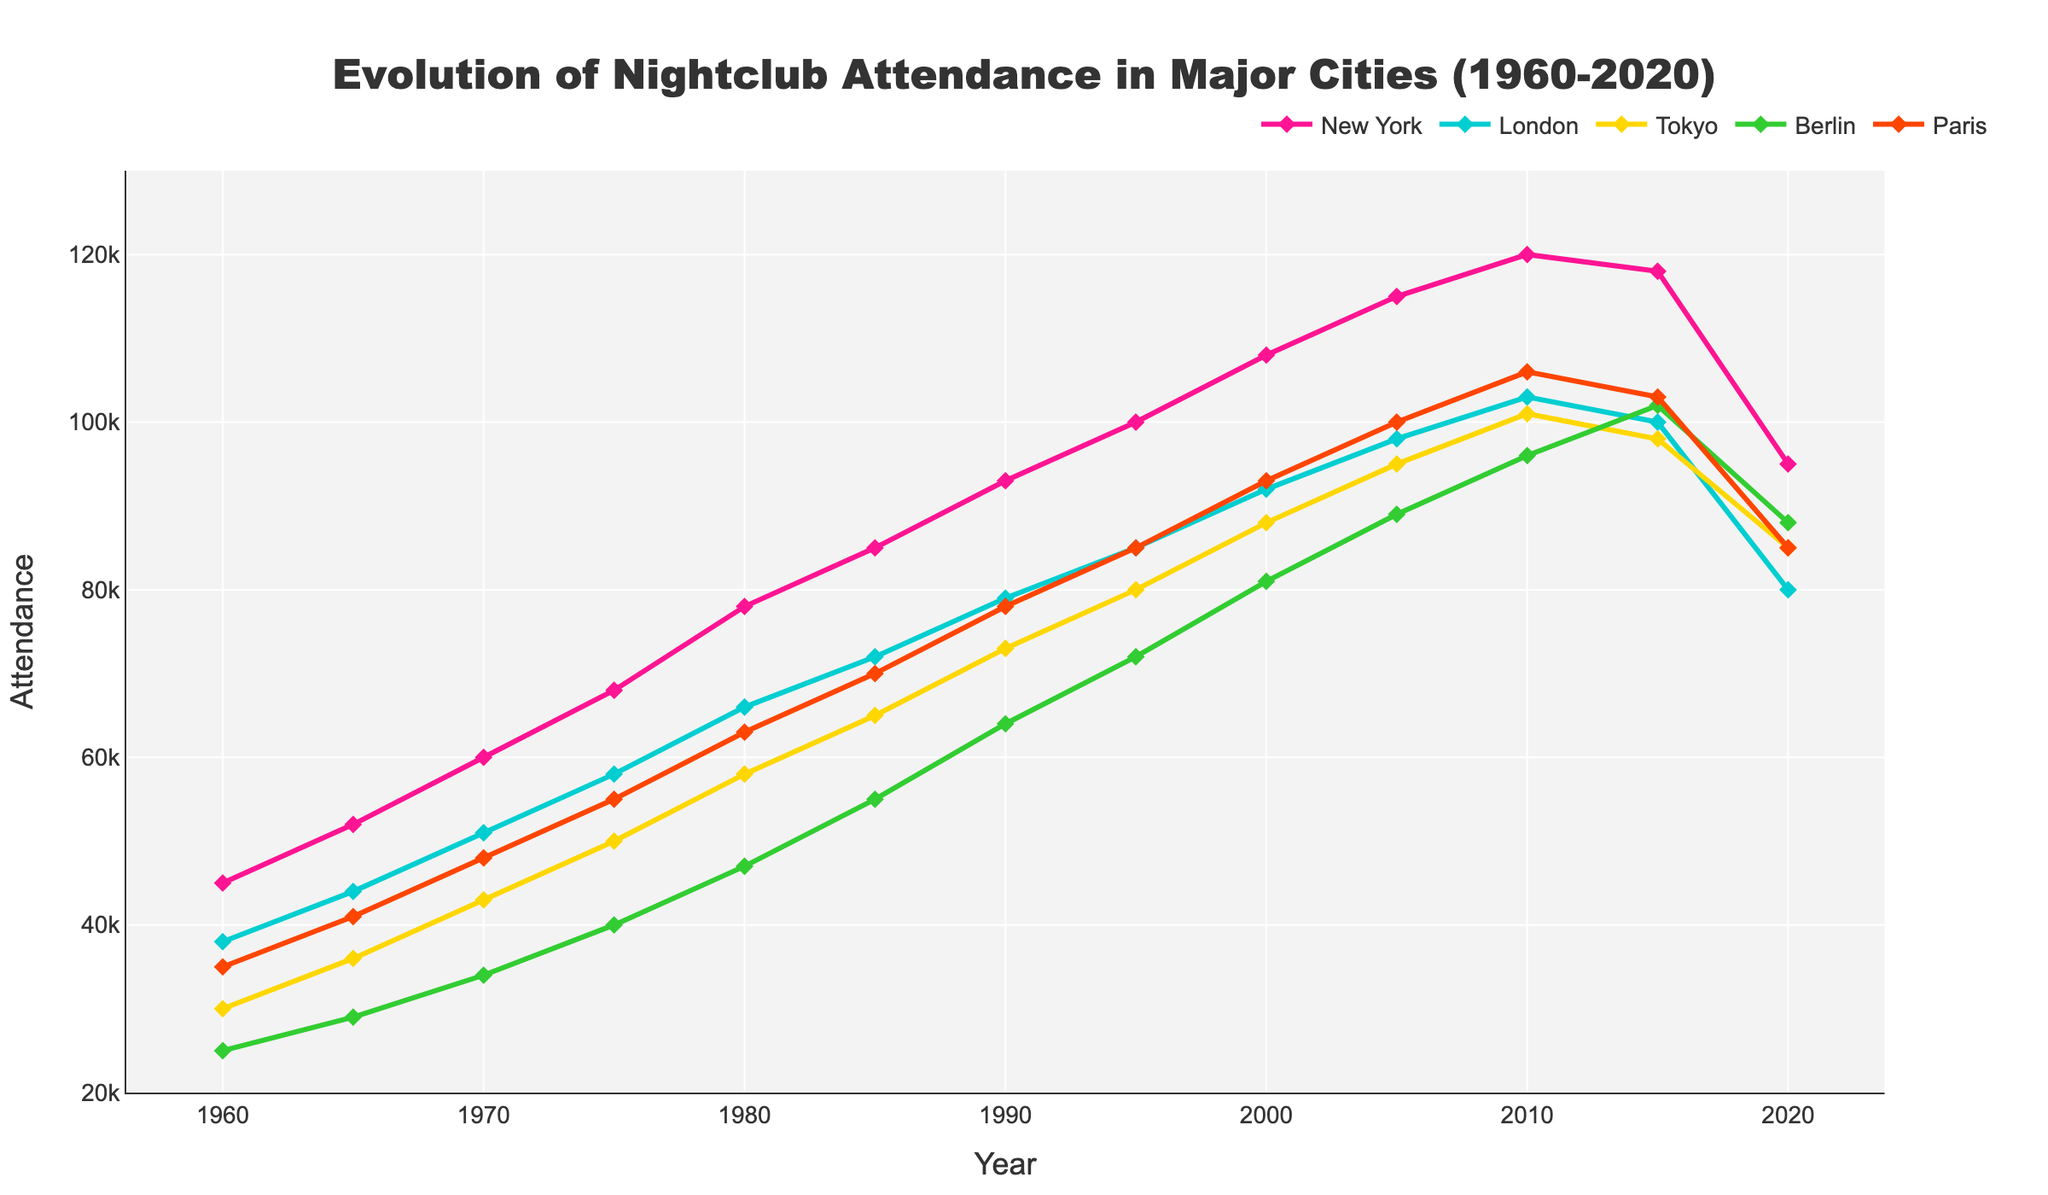Which city had the highest nightclub attendance in 1980? From the chart, the line representing New York in 1980 reaches the highest position among all cities in that year.
Answer: New York Which city experienced the steepest increase in nightclub attendance between 1960 and 1970? From 1960 to 1970, the slope of the line for New York is the steepest, showing the most significant increase.
Answer: New York What was the average nightclub attendance for Paris from 2010 to 2020? From the chart, the figures for Paris in 2010 and 2020 are 106,000 and 85,000 respectively. Calculate the average: (106,000 + 85,000) / 2 = 95,500.
Answer: 95,500 Which city had the most significant drop in nightclub attendance from 2010 to 2020? The line for New York shows the most significant decline from 120,000 in 2010 to 95,000 in 2020.
Answer: New York Which city had the lowest nightclub attendance in 1990? In 1990, Berlin's line is at the lowest position compared to other cities at that time, indicating the lowest attendance.
Answer: Berlin How did the change in nightclub attendance in Tokyo between 2000 and 2010 compare to the change in London during the same period? In Tokyo, attendance increased from 88,000 in 2000 to 101,000 in 2010, an increase of 13,000. In London, it increased from 92,000 to 103,000, an increase of 11,000.
Answer: Tokyo increased more By how much did the nightclub attendance in Berlin change from 1980 to 2010? Attendance in Berlin increased from 47,000 in 1980 to 96,000 in 2010. Calculate the change: 96,000 - 47,000 = 49,000.
Answer: 49,000 Was nightclub attendance in New York higher or lower than in Paris in 2000? In 2000, New York's line is above Paris's, indicating higher attendance in New York.
Answer: Higher Which city saw a decrease in nightclub attendance from 2015 to 2020? All lines except Berlin’s show a decrease, but specifically for Paris, the attendance decreased from 103,000 to 85,000.
Answer: Paris In which year did London surpass Tokyo in nightclub attendance? London's line surpasses Tokyo's between 1985 and 1990. By examining the chart, it occurs in the year 1986.
Answer: 1986 